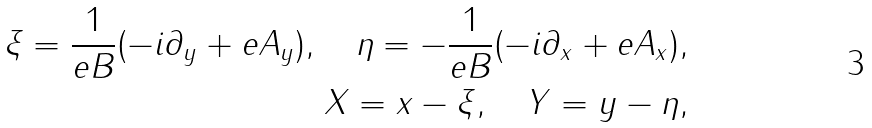Convert formula to latex. <formula><loc_0><loc_0><loc_500><loc_500>\xi = \frac { 1 } { e B } ( - i \partial _ { y } + e A _ { y } ) , \quad \eta = - \frac { 1 } { e B } ( - i \partial _ { x } + e A _ { x } ) , \\ X = x - \xi , \quad Y = y - \eta ,</formula> 